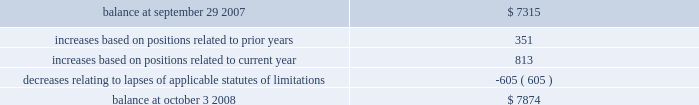Notes to consolidated financial statements 2014 ( continued ) a reconciliation of the beginning and ending amount of gross unrecognized tax benefits is as follows ( in thousands ) : .
The company 2019s major tax jurisdictions as of october 3 , 2008 for fin 48 are the u.s. , california , and iowa .
For the u.s. , the company has open tax years dating back to fiscal year 1998 due to the carryforward of tax attributes .
For california , the company has open tax years dating back to fiscal year 2002 due to the carryforward of tax attributes .
For iowa , the company has open tax years dating back to fiscal year 2002 due to the carryforward of tax attributes .
During the year ended october 3 , 2008 , the statute of limitations period expired relating to an unrecognized tax benefit .
The expiration of the statute of limitations period resulted in the recognition of $ 0.6 million of previously unrecognized tax benefit , which impacted the effective tax rate , and $ 0.5 million of accrued interest related to this tax position was reversed during the year .
Including this reversal , total year-to-date accrued interest related to the company 2019s unrecognized tax benefits was a benefit of $ 0.4 million .
10 .
Stockholders 2019 equity common stock the company is authorized to issue ( 1 ) 525000000 shares of common stock , par value $ 0.25 per share , and ( 2 ) 25000000 shares of preferred stock , without par value .
Holders of the company 2019s common stock are entitled to such dividends as may be declared by the company 2019s board of directors out of funds legally available for such purpose .
Dividends may not be paid on common stock unless all accrued dividends on preferred stock , if any , have been paid or declared and set aside .
In the event of the company 2019s liquidation , dissolution or winding up , the holders of common stock will be entitled to share pro rata in the assets remaining after payment to creditors and after payment of the liquidation preference plus any unpaid dividends to holders of any outstanding preferred stock .
Each holder of the company 2019s common stock is entitled to one vote for each such share outstanding in the holder 2019s name .
No holder of common stock is entitled to cumulate votes in voting for directors .
The company 2019s second amended and restated certificate of incorporation provides that , unless otherwise determined by the company 2019s board of directors , no holder of common stock has any preemptive right to purchase or subscribe for any stock of any class which the company may issue or sell .
In march 2007 , the company repurchased approximately 4.3 million of its common shares for $ 30.1 million as authorized by the company 2019s board of directors .
The company has no publicly disclosed stock repurchase plans .
At october 3 , 2008 , the company had 170322804 shares of common stock issued and 165591830 shares outstanding .
Preferred stock the company 2019s second amended and restated certificate of incorporation permits the company to issue up to 25000000 shares of preferred stock in one or more series and with rights and preferences that may be fixed or designated by the company 2019s board of directors without any further action by the company 2019s stockholders .
The designation , powers , preferences , rights and qualifications , limitations and restrictions of the preferred stock of each skyworks solutions , inc .
2008 annual report %%transmsg*** transmitting job : a51732 pcn : 099000000 ***%%pcmsg|103 |00005|yes|no|03/26/2009 13:34|0|0|page is valid , no graphics -- color : d| .
In march 2007what was the share price in the company repurchased of 4.3 million of its common shares at $ 30.1 million as authorized by the company 2019s board of directors .? 
Computations: (30.1 / 4.3)
Answer: 7.0. 